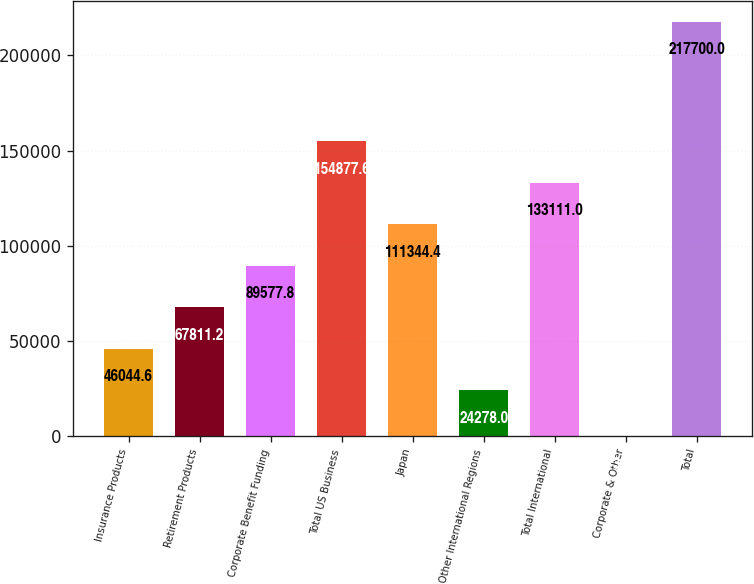Convert chart. <chart><loc_0><loc_0><loc_500><loc_500><bar_chart><fcel>Insurance Products<fcel>Retirement Products<fcel>Corporate Benefit Funding<fcel>Total US Business<fcel>Japan<fcel>Other International Regions<fcel>Total International<fcel>Corporate & Other<fcel>Total<nl><fcel>46044.6<fcel>67811.2<fcel>89577.8<fcel>154878<fcel>111344<fcel>24278<fcel>133111<fcel>34<fcel>217700<nl></chart> 